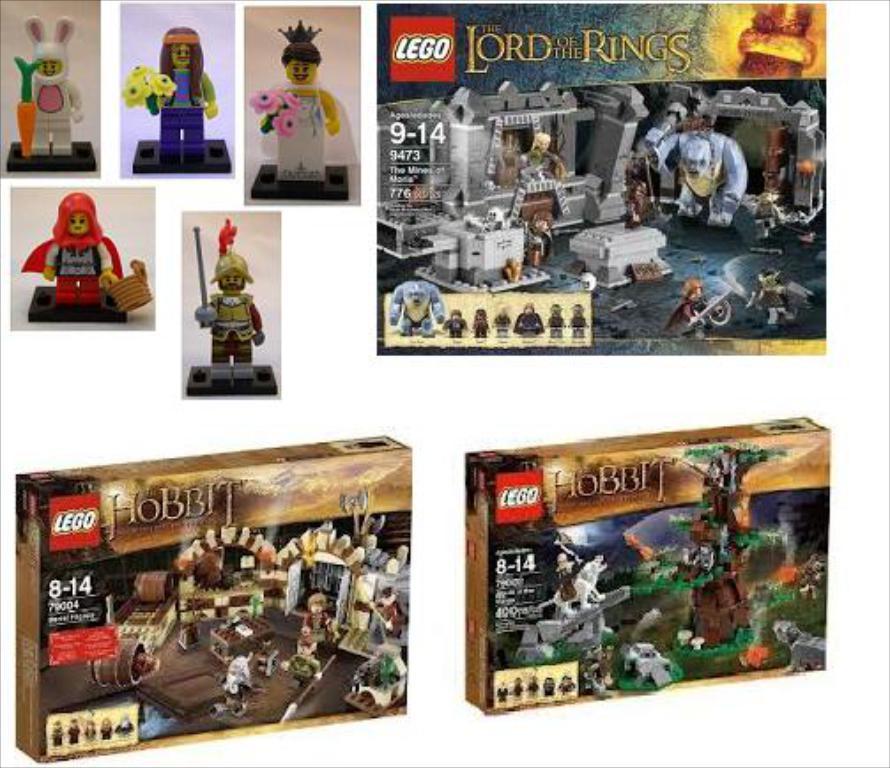Can you describe this image briefly? In the image there are boxes with images and something written on it. And also there is a poster with few images. And there are few toys. 